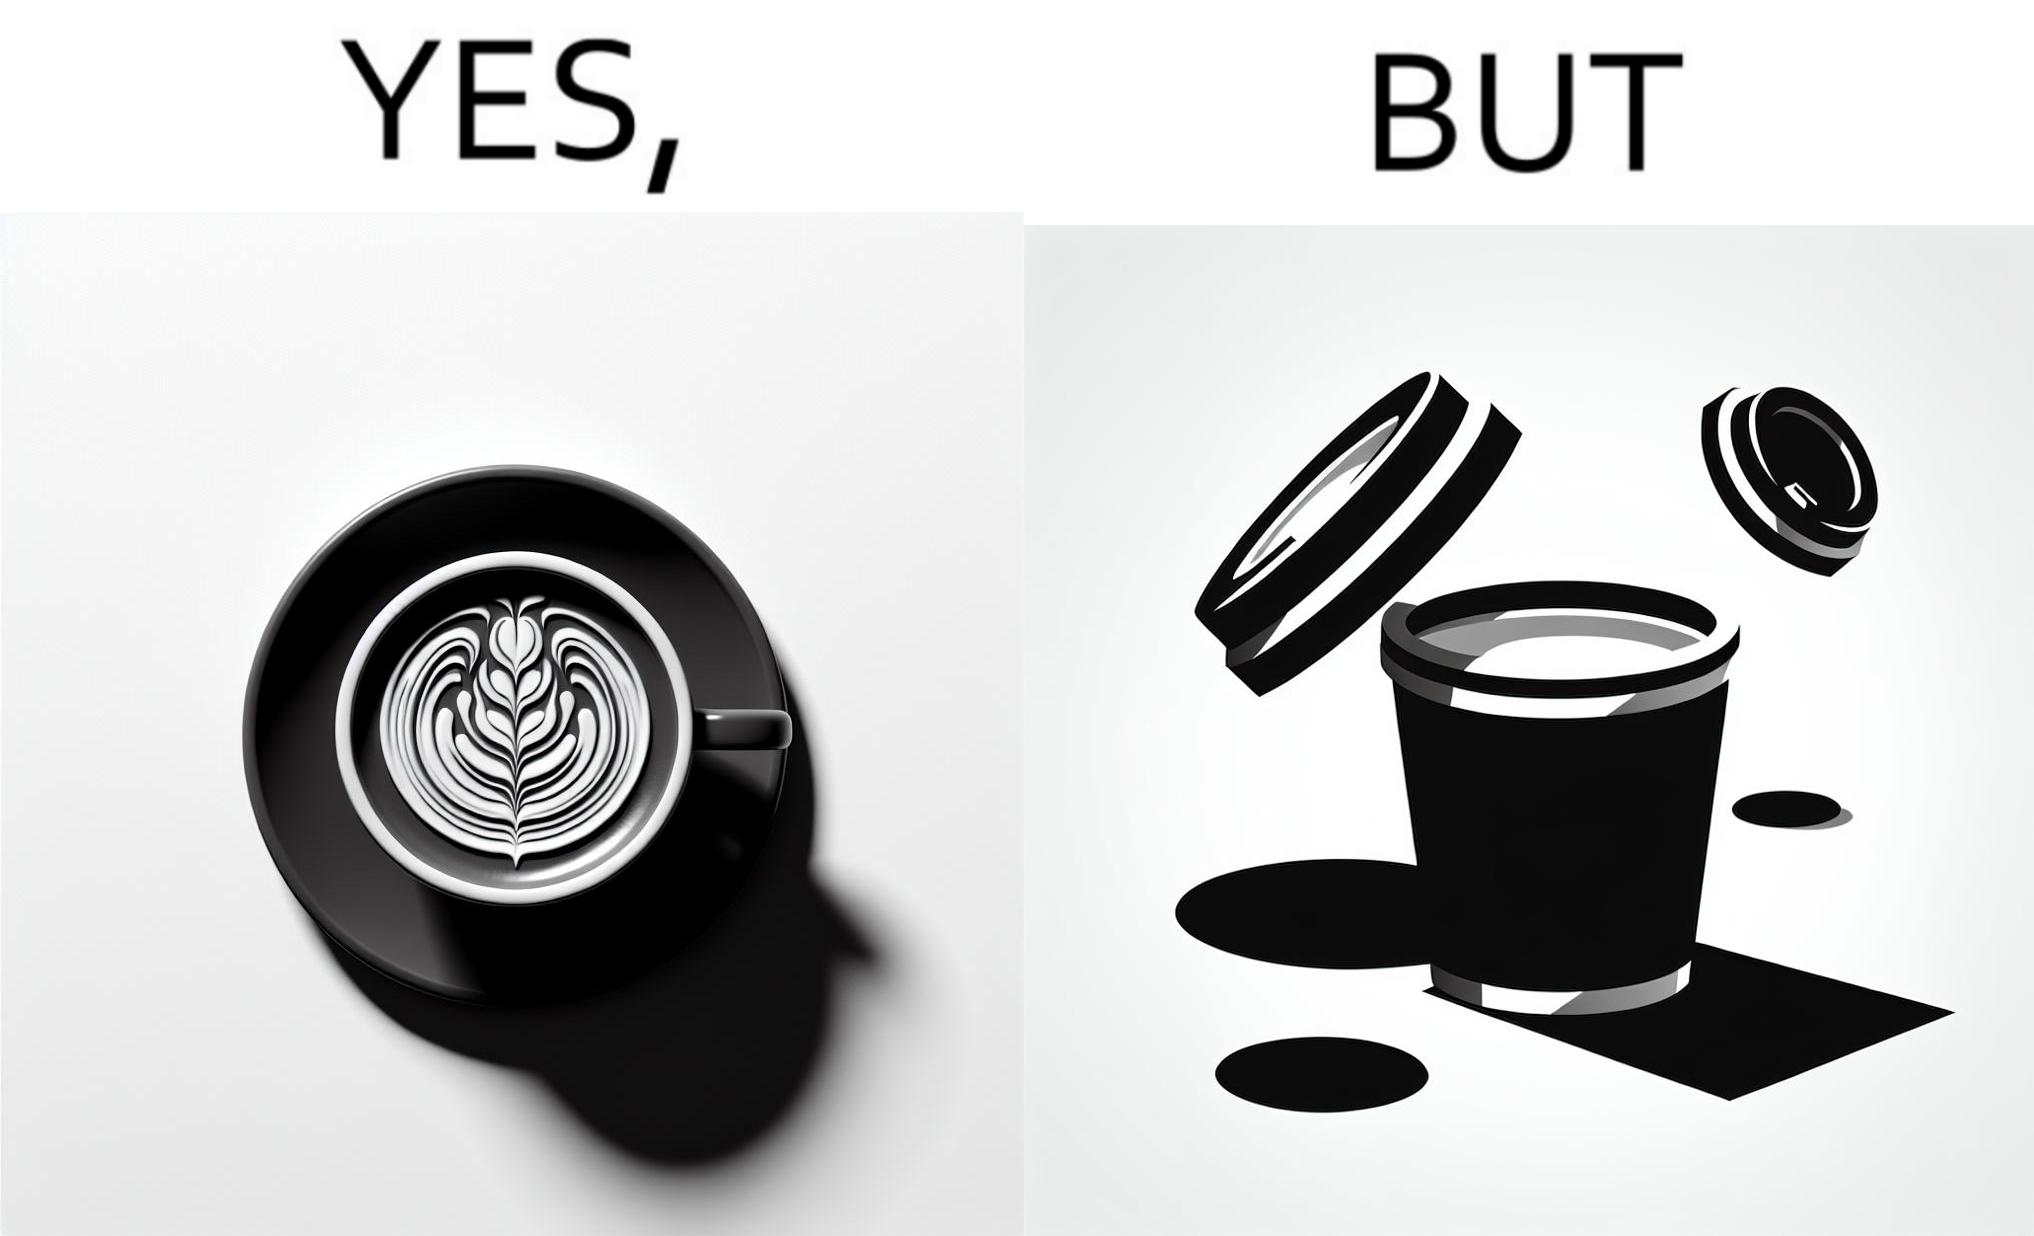Describe the contrast between the left and right parts of this image. In the left part of the image: It is a cup of coffee with latte art In the right part of the image: It is a cup of coffee with its lid on top 